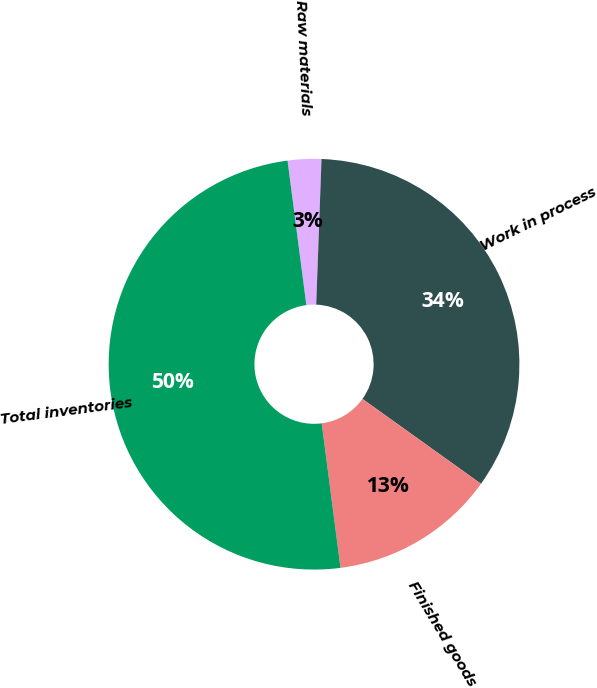<chart> <loc_0><loc_0><loc_500><loc_500><pie_chart><fcel>Raw materials<fcel>Work in process<fcel>Finished goods<fcel>Total inventories<nl><fcel>2.64%<fcel>34.31%<fcel>13.05%<fcel>50.0%<nl></chart> 